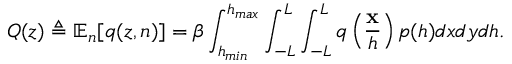Convert formula to latex. <formula><loc_0><loc_0><loc_500><loc_500>Q ( z ) \triangle q \mathbb { E } _ { n } [ q ( z , n ) ] = \beta \int _ { h _ { \min } } ^ { h _ { \max } } \int _ { - L } ^ { L } \int _ { - L } ^ { L } q \left ( \frac { x } { h } \right ) p ( h ) d x d y d h .</formula> 